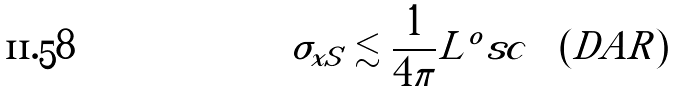Convert formula to latex. <formula><loc_0><loc_0><loc_500><loc_500>\sigma _ { x S } \lesssim \frac { 1 } { 4 \pi } L ^ { o } s c \quad ( D A R )</formula> 